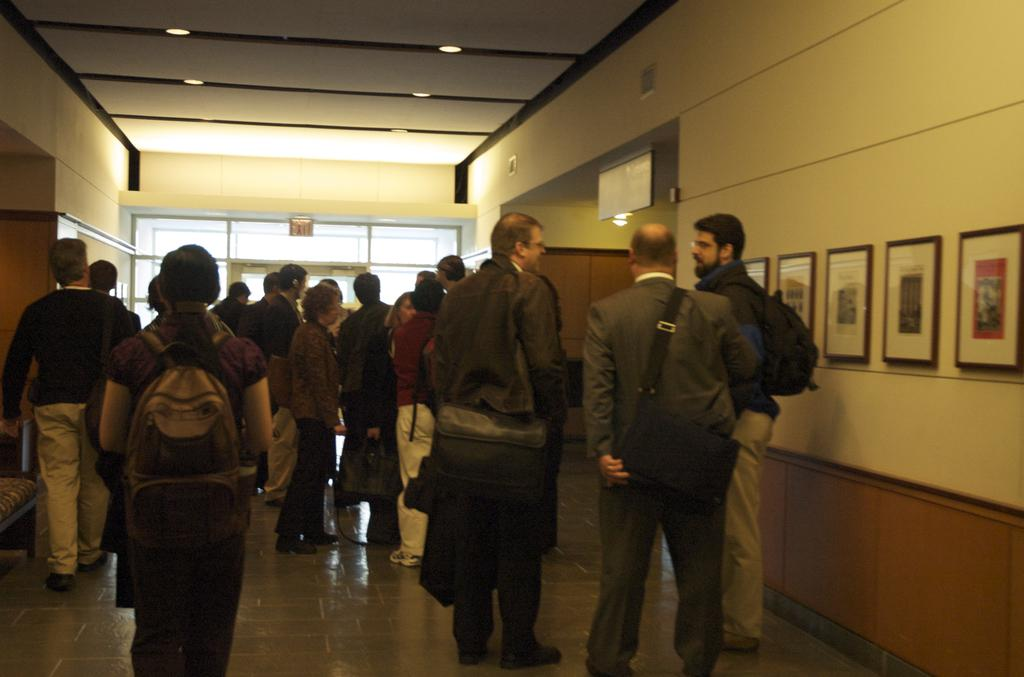What are the people in the image doing? The people in the image are standing in a building. What can be seen on the wall in the image? There are photo frames on a wall in the image. Where are the photo frames located in the image? The photo frames are on the right side of the image. What is visible at the top of the image? There are lights at the top of the image. What type of door is at the back of the image? There is a glass door at the back of the image. What hobbies do the people in the image have? There are no people in the image, so we cannot determine their hobbies. How many volleyballs are visible in the image? There are no volleyballs present in the image. 